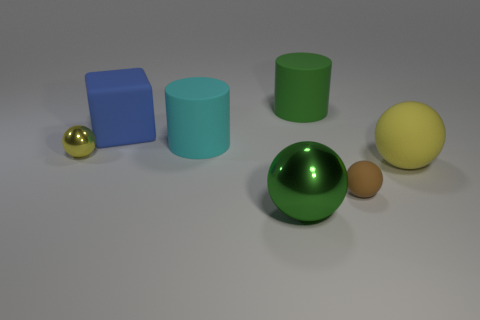Add 1 big metal spheres. How many objects exist? 8 Subtract all balls. How many objects are left? 3 Subtract 1 green cylinders. How many objects are left? 6 Subtract all cubes. Subtract all yellow spheres. How many objects are left? 4 Add 4 metallic balls. How many metallic balls are left? 6 Add 5 brown metal cylinders. How many brown metal cylinders exist? 5 